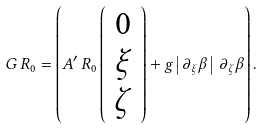<formula> <loc_0><loc_0><loc_500><loc_500>G \, R _ { 0 } = \left ( A ^ { \prime } \, R _ { 0 } \left ( \begin{array} { c } 0 \\ \xi \\ \zeta \end{array} \right ) + g \left | \, \partial _ { \xi } \beta \, \right | \, \partial _ { \zeta } \beta \right ) .</formula> 